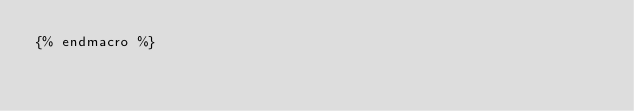Convert code to text. <code><loc_0><loc_0><loc_500><loc_500><_SQL_>{% endmacro %}
</code> 